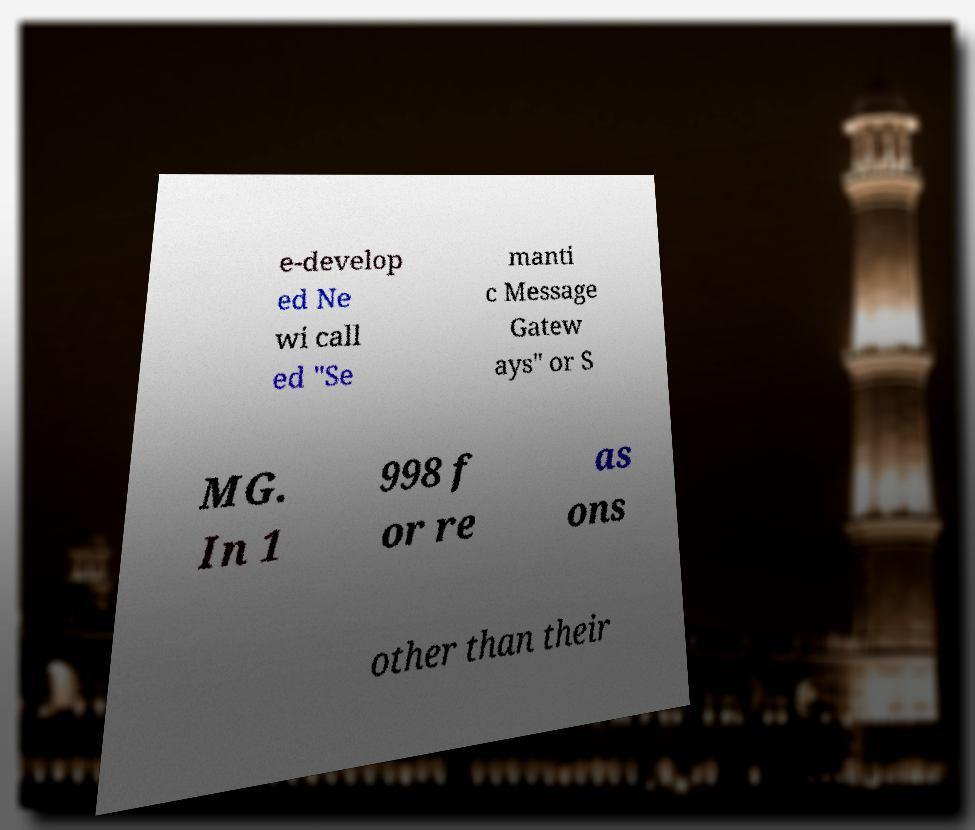I need the written content from this picture converted into text. Can you do that? e-develop ed Ne wi call ed "Se manti c Message Gatew ays" or S MG. In 1 998 f or re as ons other than their 